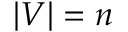<formula> <loc_0><loc_0><loc_500><loc_500>| V | = n</formula> 